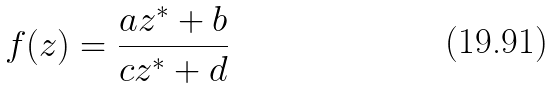<formula> <loc_0><loc_0><loc_500><loc_500>f ( z ) = \frac { a z ^ { * } + b } { c z ^ { * } + d }</formula> 